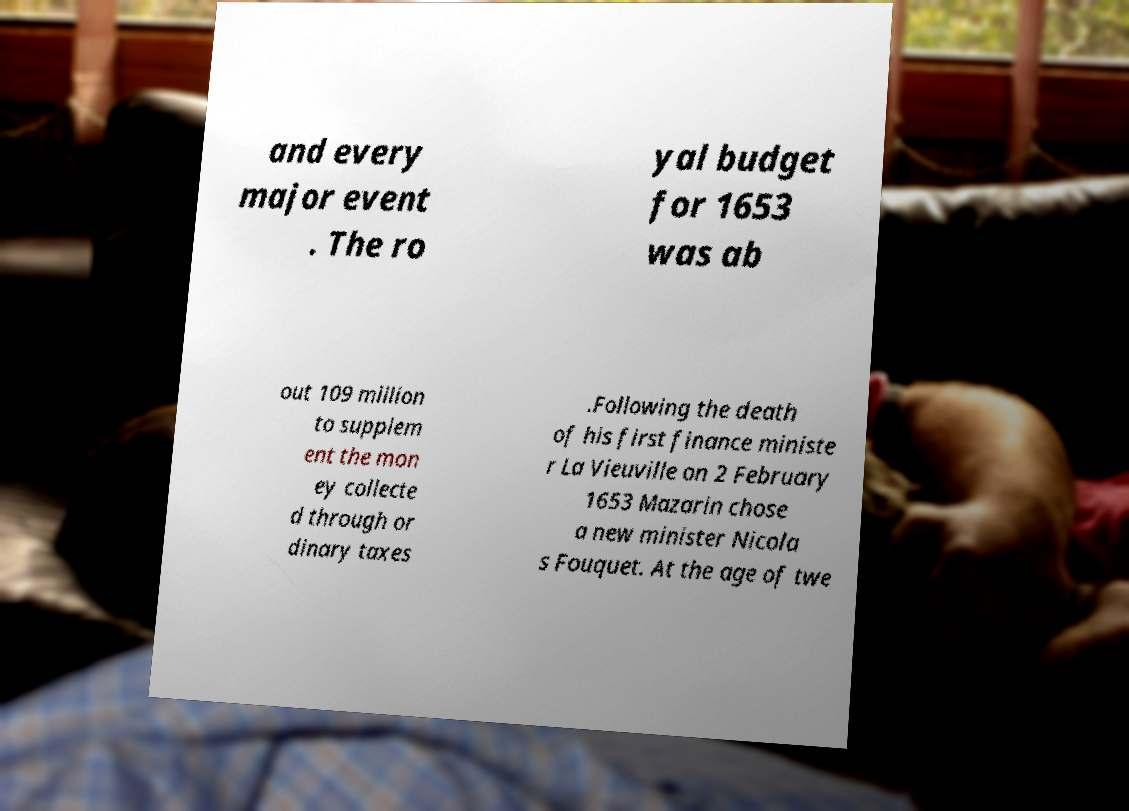What messages or text are displayed in this image? I need them in a readable, typed format. and every major event . The ro yal budget for 1653 was ab out 109 million to supplem ent the mon ey collecte d through or dinary taxes .Following the death of his first finance ministe r La Vieuville on 2 February 1653 Mazarin chose a new minister Nicola s Fouquet. At the age of twe 